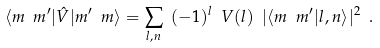<formula> <loc_0><loc_0><loc_500><loc_500>\langle m \ m ^ { \prime } | \hat { V } | m ^ { \prime } \ m \rangle = \sum _ { l , n } \ ( - 1 ) ^ { l } \ V ( l ) \ | \langle m \ m ^ { \prime } | l , n \rangle | ^ { 2 } \ .</formula> 